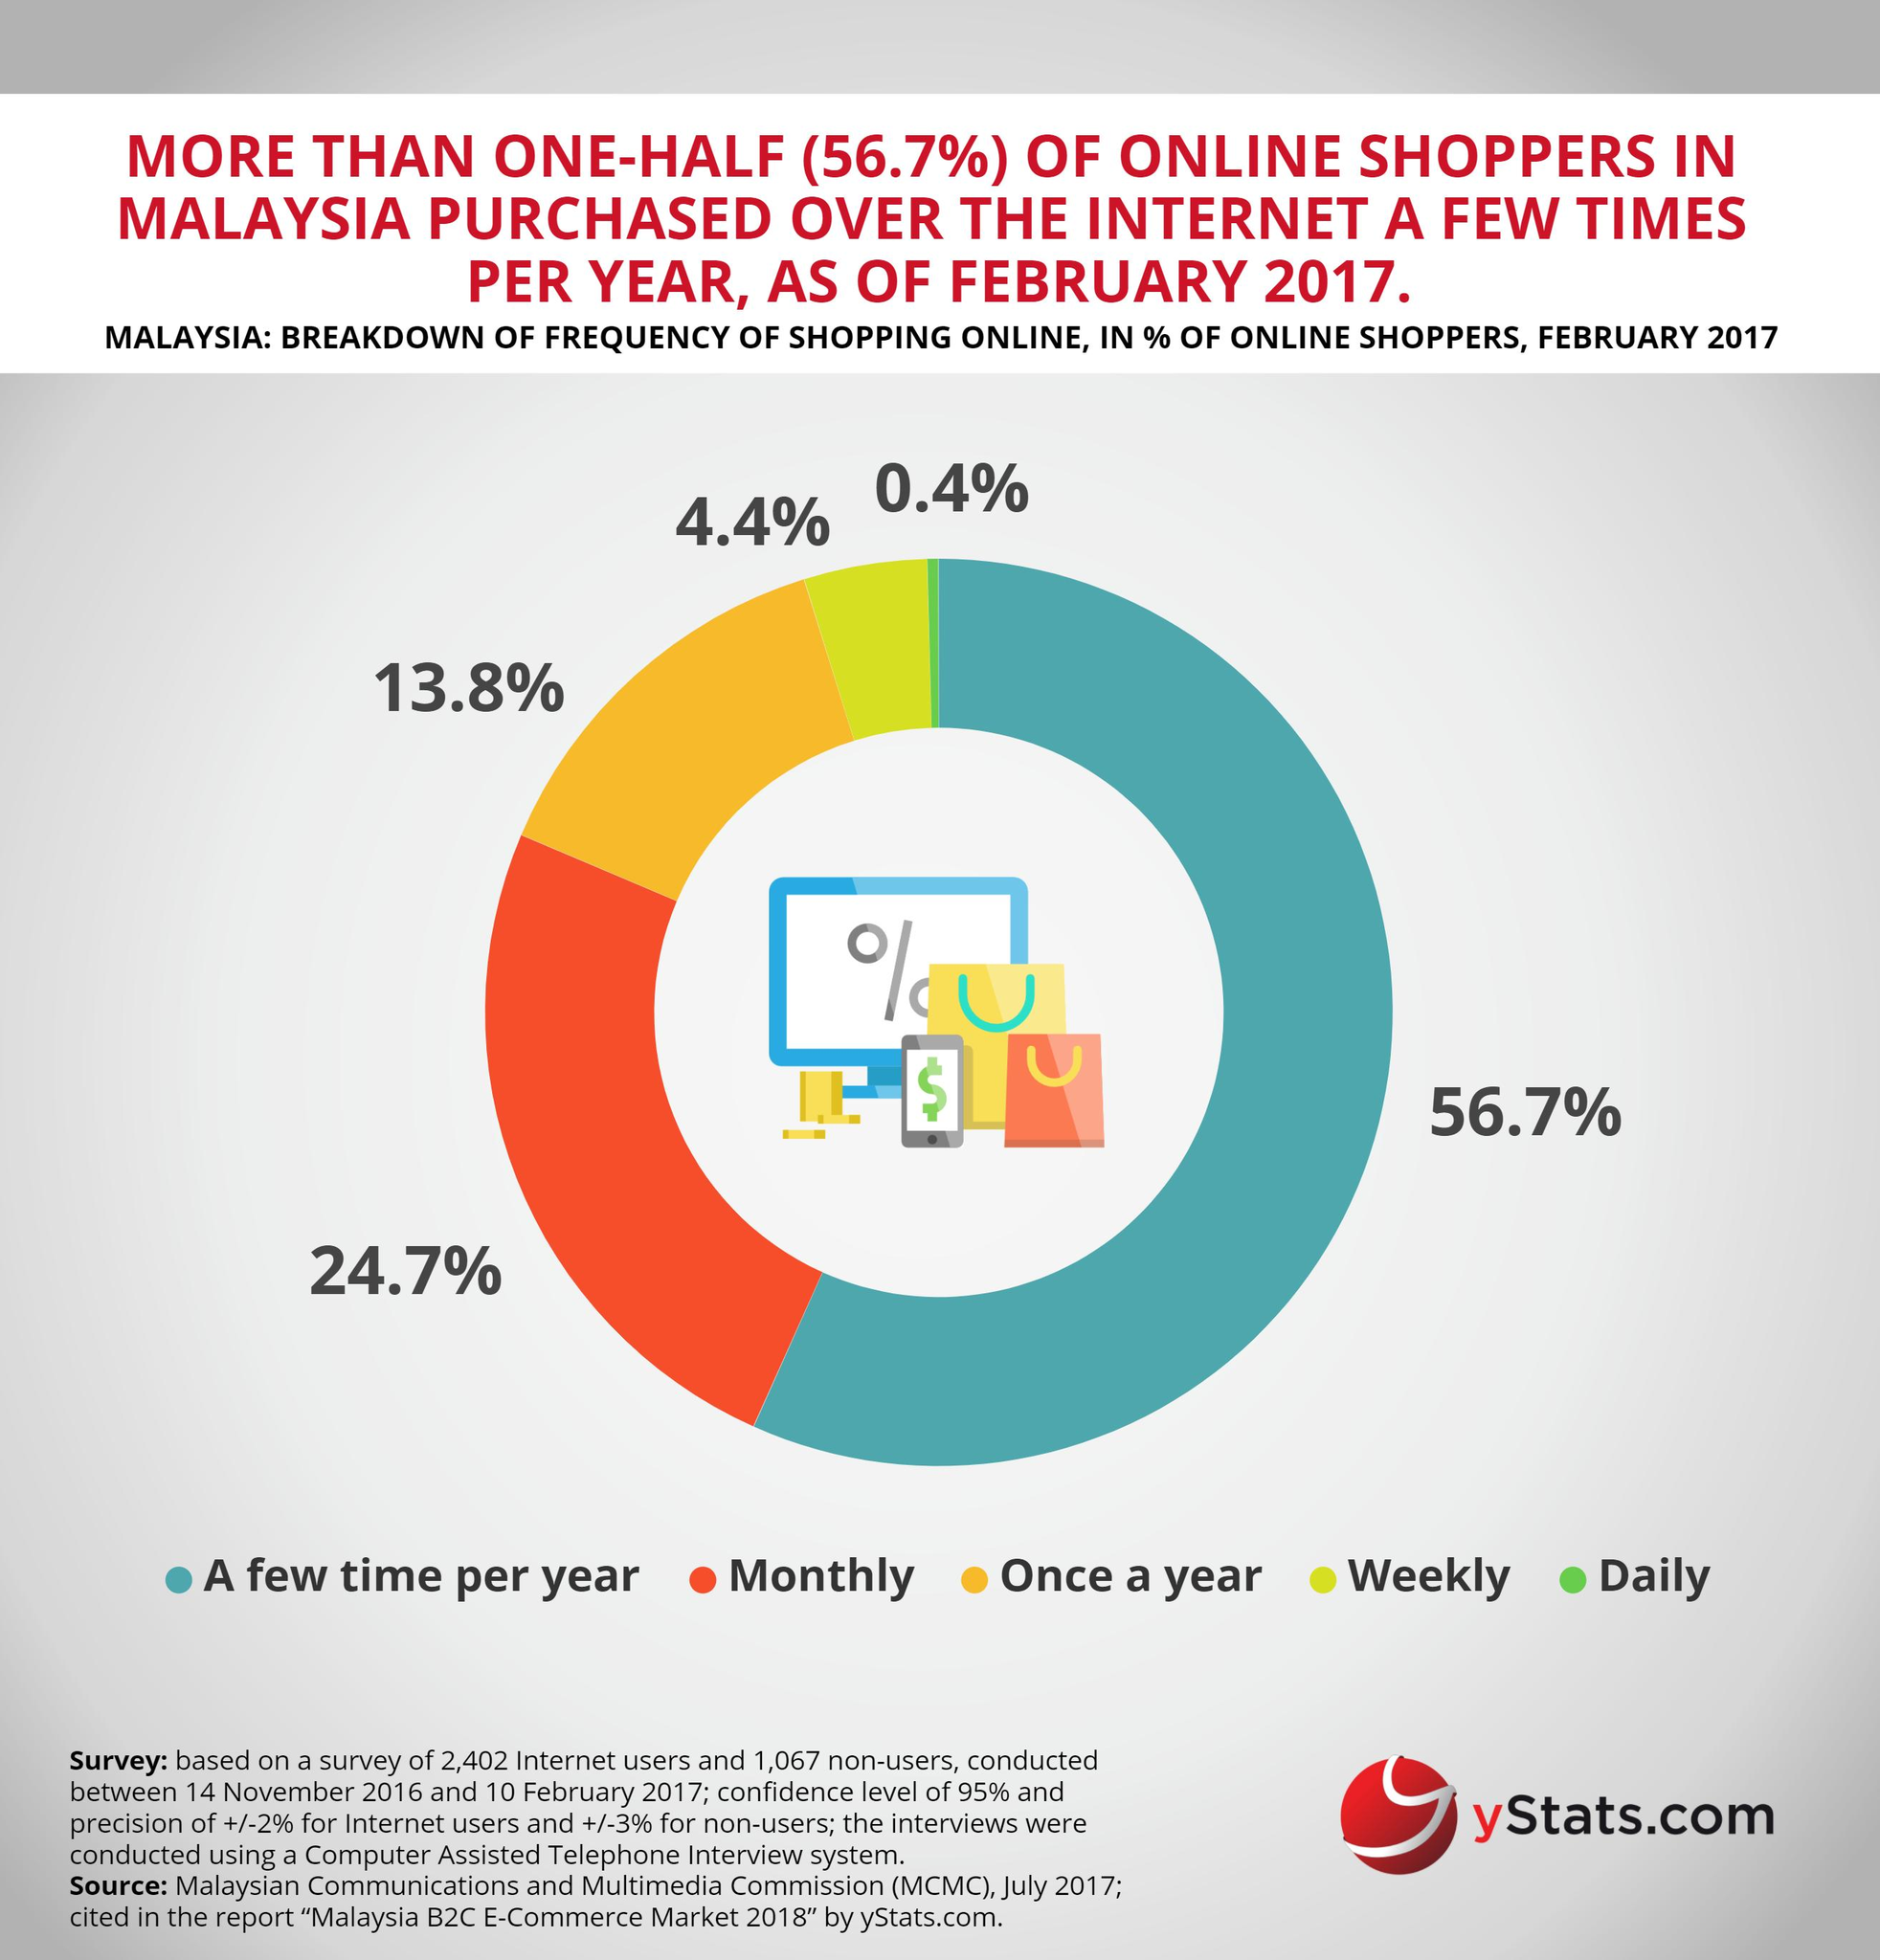List a handful of essential elements in this visual. According to a study, only 4.4% of Malaysian users shop online on a weekly basis. According to recent data, 24.7% of users shop online on a monthly basis. The infographic lists five different types of online shopping methods. The second highest frequency of online shopping belongs to monthly online shoppers. The third most frequent type of online shoppers are those who shop once a year. 